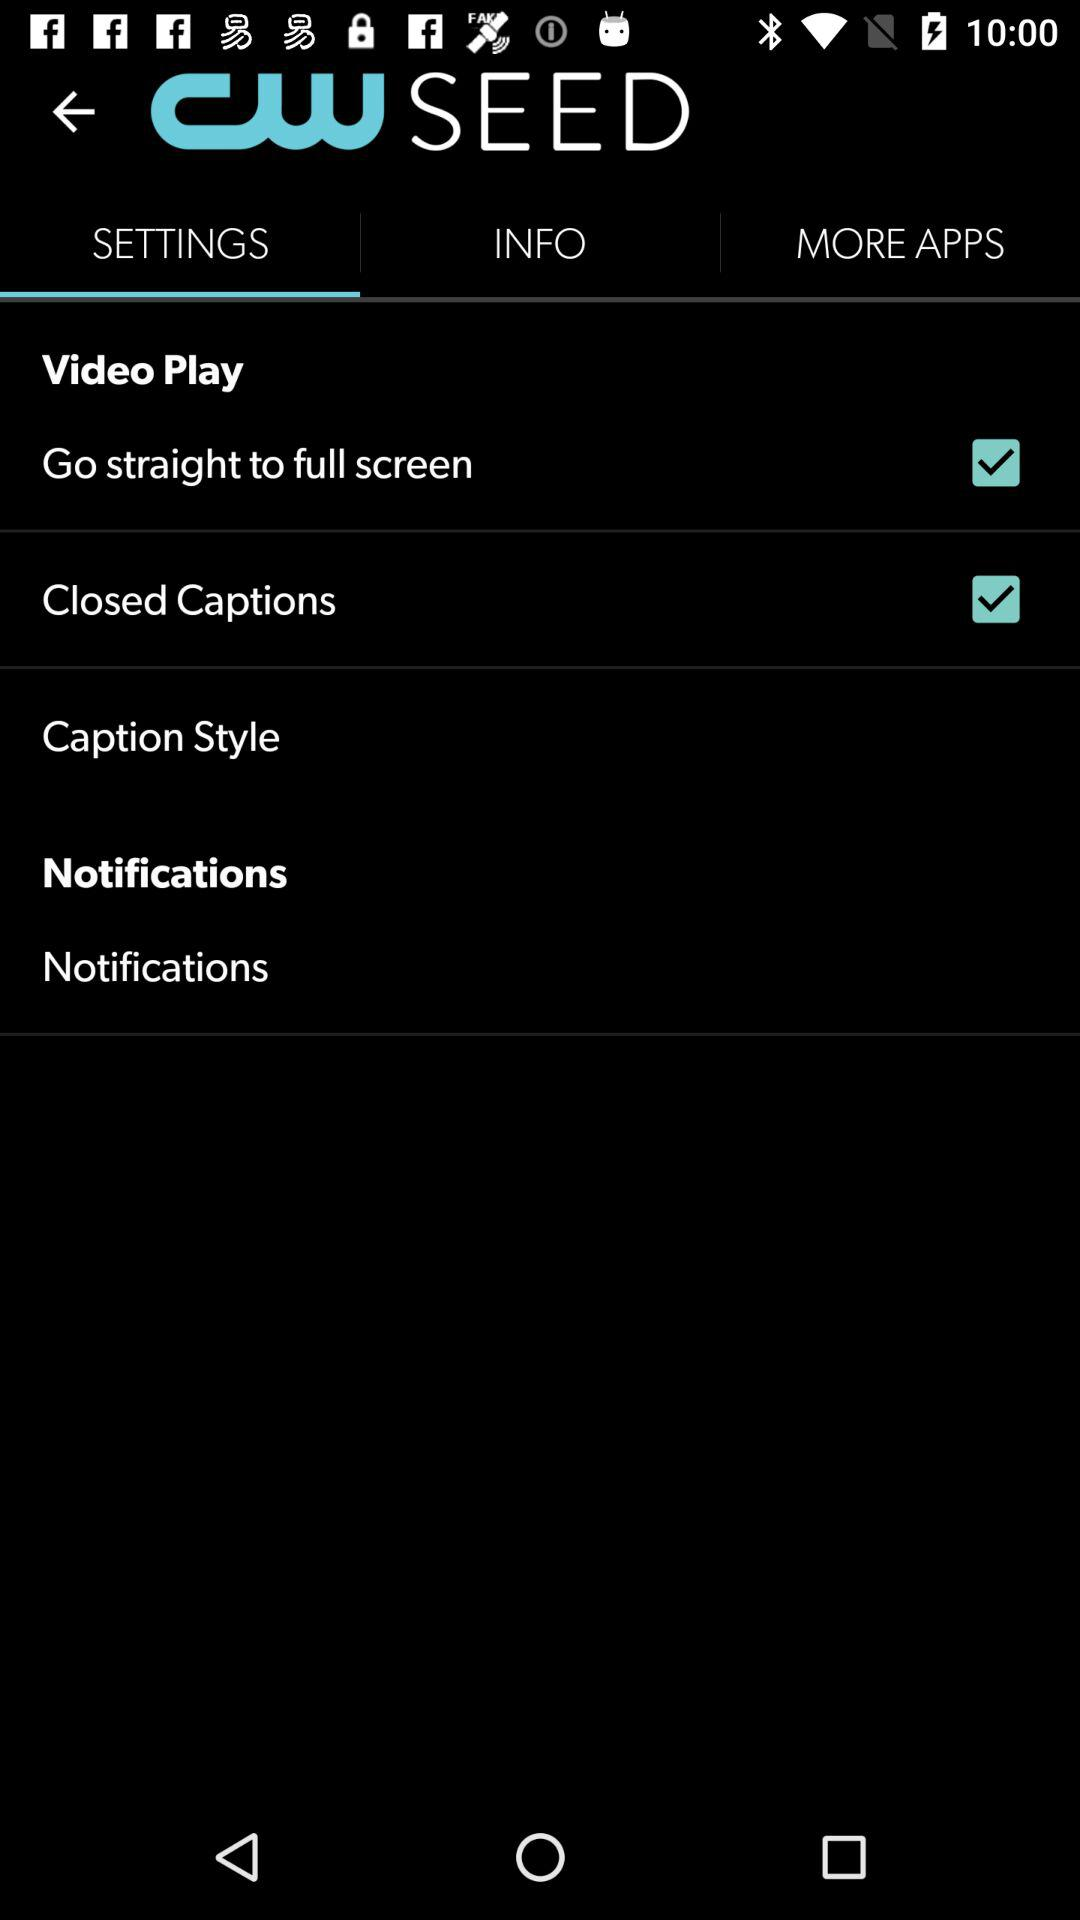What is the application name? The application name is "CW SEED". 